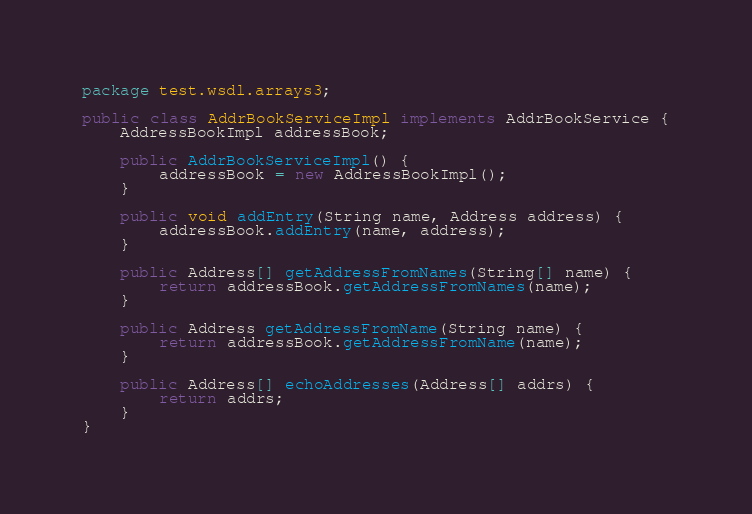<code> <loc_0><loc_0><loc_500><loc_500><_Java_>package test.wsdl.arrays3;

public class AddrBookServiceImpl implements AddrBookService {
    AddressBookImpl addressBook;

    public AddrBookServiceImpl() {
        addressBook = new AddressBookImpl();
    }

    public void addEntry(String name, Address address) {
        addressBook.addEntry(name, address);
    }

    public Address[] getAddressFromNames(String[] name) {
        return addressBook.getAddressFromNames(name);
    }

    public Address getAddressFromName(String name) {
        return addressBook.getAddressFromName(name);
    }

    public Address[] echoAddresses(Address[] addrs) {
        return addrs;
    }
}
</code> 